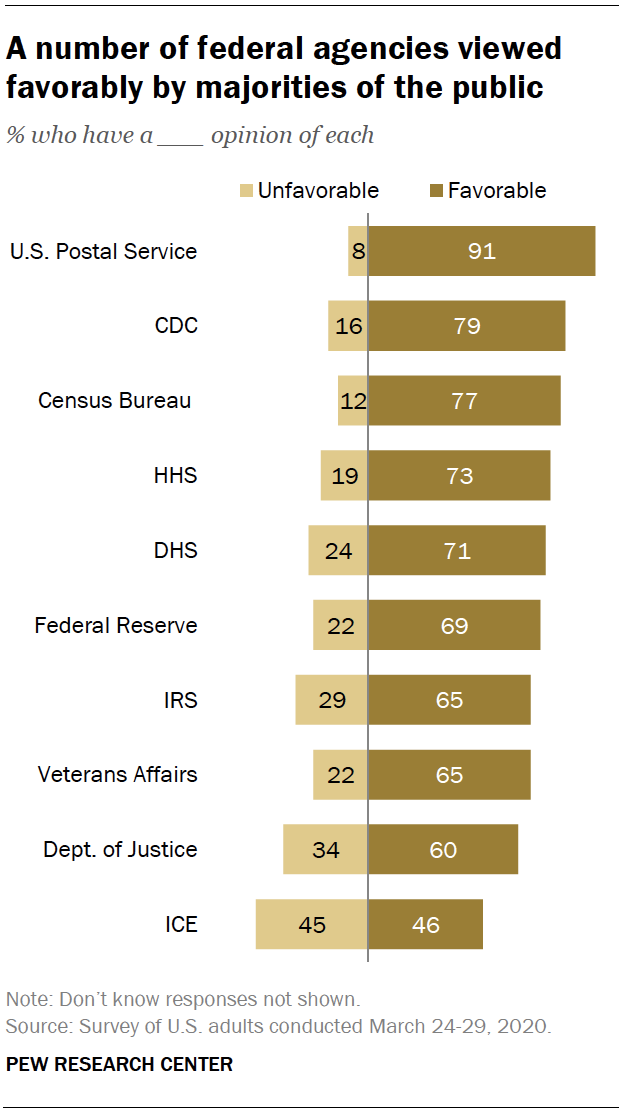Specify some key components in this picture. The favorable bar is 0.65 for the IRS. 